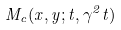Convert formula to latex. <formula><loc_0><loc_0><loc_500><loc_500>M _ { c } ( x , y ; t , \gamma ^ { 2 } t )</formula> 